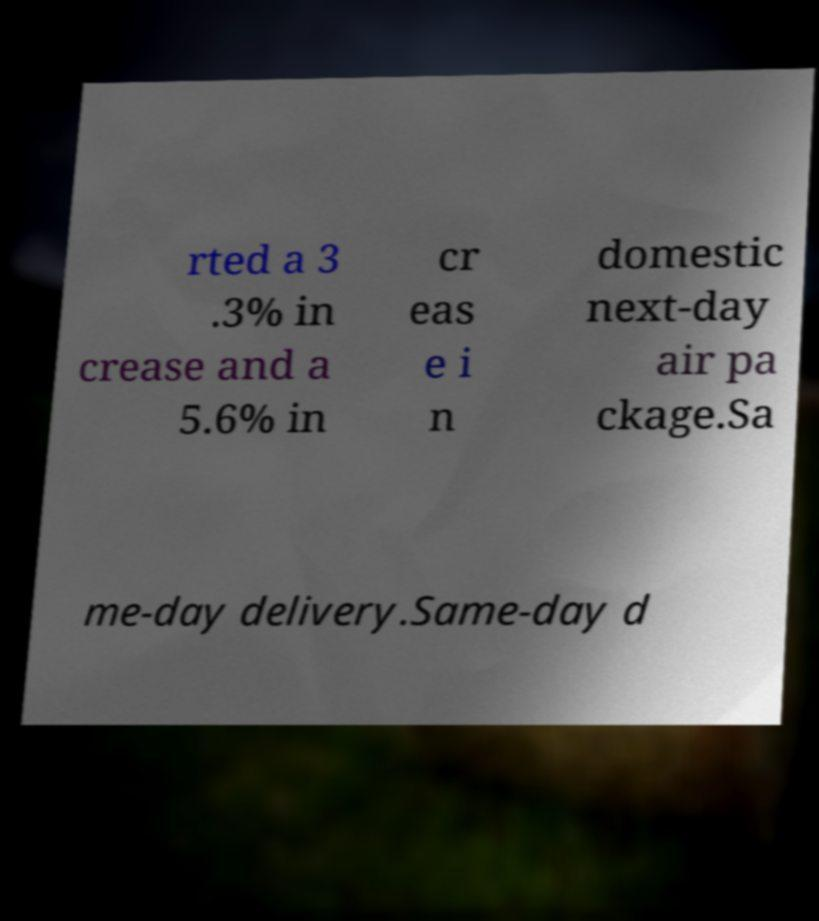What messages or text are displayed in this image? I need them in a readable, typed format. rted a 3 .3% in crease and a 5.6% in cr eas e i n domestic next-day air pa ckage.Sa me-day delivery.Same-day d 